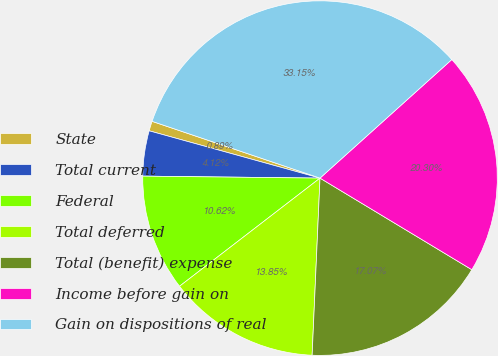Convert chart to OTSL. <chart><loc_0><loc_0><loc_500><loc_500><pie_chart><fcel>State<fcel>Total current<fcel>Federal<fcel>Total deferred<fcel>Total (benefit) expense<fcel>Income before gain on<fcel>Gain on dispositions of real<nl><fcel>0.89%<fcel>4.12%<fcel>10.62%<fcel>13.85%<fcel>17.07%<fcel>20.3%<fcel>33.15%<nl></chart> 